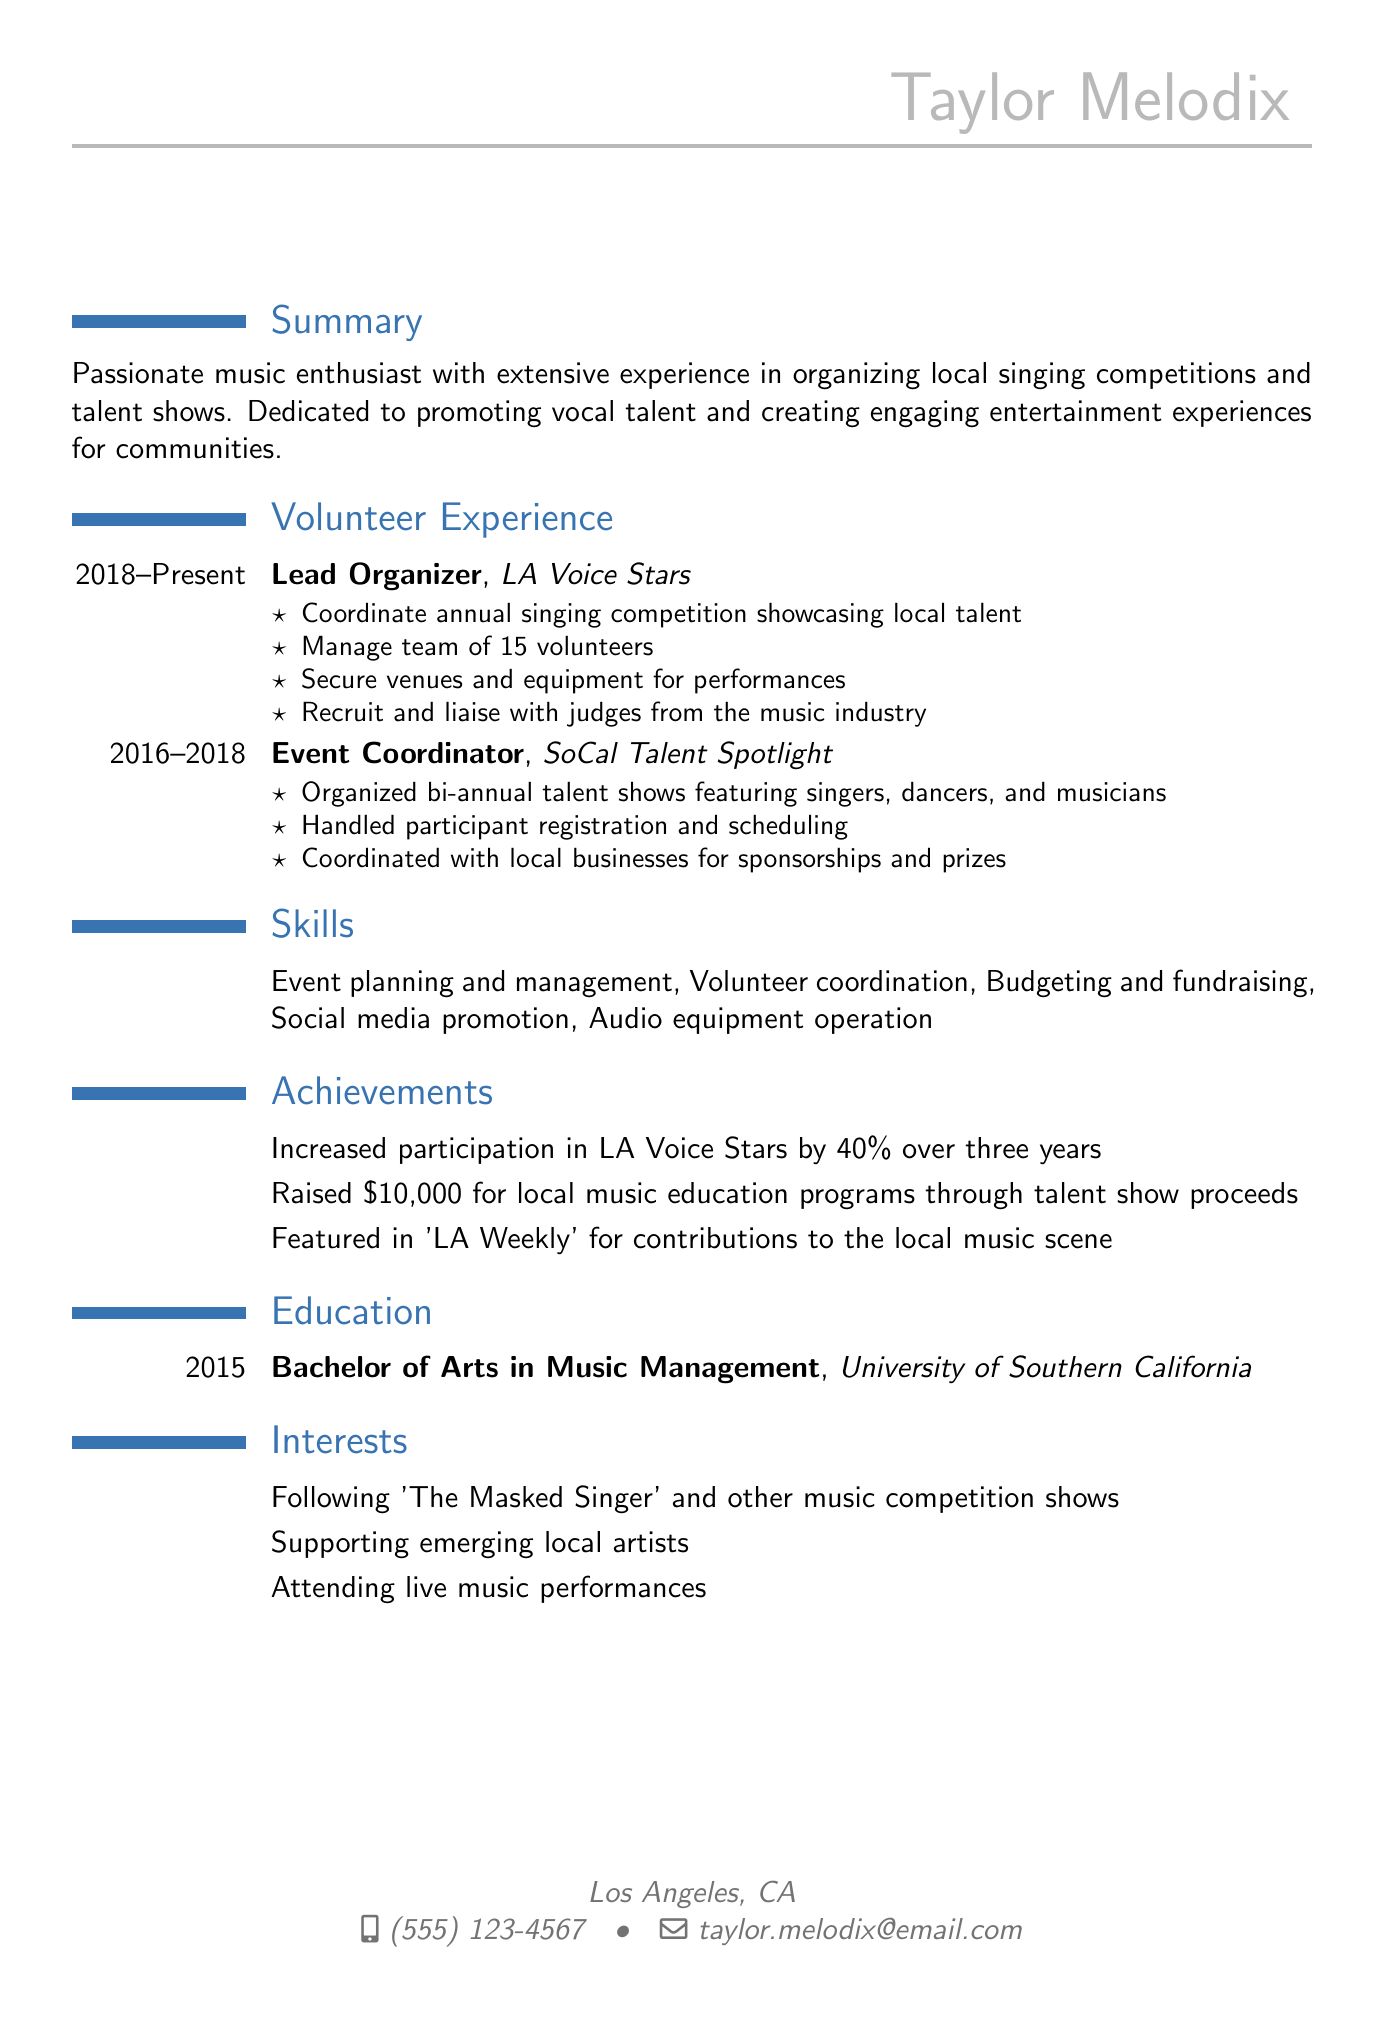What is the name of the individual? The name is listed at the top of the CV in the personal info section.
Answer: Taylor Melodix What is the duration of the volunteer work with LA Voice Stars? The duration is specified as part of the volunteer experience section of the document.
Answer: 2018 - Present What responsibilities did Taylor have as Lead Organizer? The responsibilities are listed in bullet points under the relevant volunteer experience section.
Answer: Coordinate annual singing competition showcasing local talent How much money was raised for local music education programs? The amount raised is mentioned in the achievements section of the CV.
Answer: $10,000 In which university did Taylor obtain a degree? The institution is specified in the education section of the CV.
Answer: University of Southern California What is one of Taylor’s interests related to music competitions? The interests are listed clearly in the interests section of the CV.
Answer: Following 'The Masked Singer' and other music competition shows How many volunteers did Taylor manage in LA Voice Stars? This information is provided in the responsibilities outlined under the Lead Organizer position.
Answer: 15 What degree did Taylor earn? The degree is mentioned under the education section of the CV.
Answer: Bachelor of Arts in Music Management 